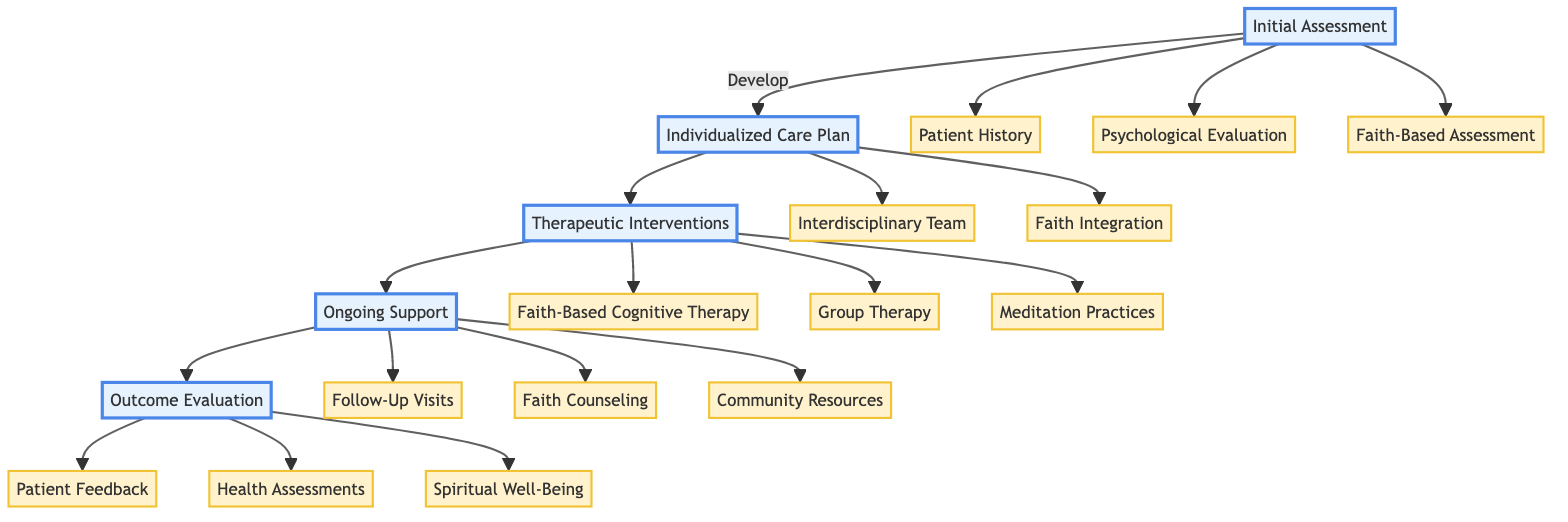What are the three components of the Initial Assessment? The diagram shows three components branching from the Initial Assessment node: Patient History, Psychological Evaluation, and Faith-Based Assessment.
Answer: Patient History, Psychological Evaluation, Faith-Based Assessment How many elements are present in the Individualized Care Plan? In the diagram, the Individualized Care Plan contains two main components: Interdisciplinary Team and Faith Integration. Therefore, there are two elements.
Answer: 2 What does the Faith Integration component include? Faith Integration is broken down into three specific activities: Prayer Sessions, Scripture Reading, and Faith Community Engagement, which are listed under it in the diagram.
Answer: Prayer Sessions, Scripture Reading, Faith Community Engagement Which professional is associated with the Interdisciplinary Team? In the diagram, the professionals listed under the Interdisciplinary Team are Psychologist, Chaplain, and Social Worker. Hence, any of these can be an answer, but focusing on one, Chaplain is directly noted for spiritual support.
Answer: Chaplain What is the purpose of Follow-Up Visits in the Ongoing Support section? The Ongoing Support node leads to Follow-Up Visits, which indicates it is a means to ensure continued medical and spiritual check-ins, as per the description in the diagram.
Answer: Regular follow-up visits including both medical and spiritual check-ins Which assessment tool is used for Health Assessments? The diagram specifies that SF-36 Health Survey is the tool utilized under the Health Assessments node for evaluating the patient's health improvements.
Answer: SF-36 Health Survey What type of therapy aligns with the patient’s faith according to the Therapeutic Interventions? The therapies are listed in the diagram under Therapeutic Interventions, and the one that specifically utilizes faith-based principles is Faith-Based Cognitive Therapy.
Answer: Faith-Based Cognitive Therapy How does the diagram depict the flow of care? The diagram illustrates a sequential flow from Initial Assessment to Outcome Evaluation, depicting a clear path of care components that must be followed in rehabilitation.
Answer: Sequential flow from Initial Assessment to Outcome Evaluation What role does feedback play in the Outcome Evaluation stage? Patient Feedback is explicitly listed as one of the components under Outcome Evaluation, indicating it is used to assess the impact of faith integration on rehabilitation.
Answer: Assess how faith integration has impacted their rehabilitation 